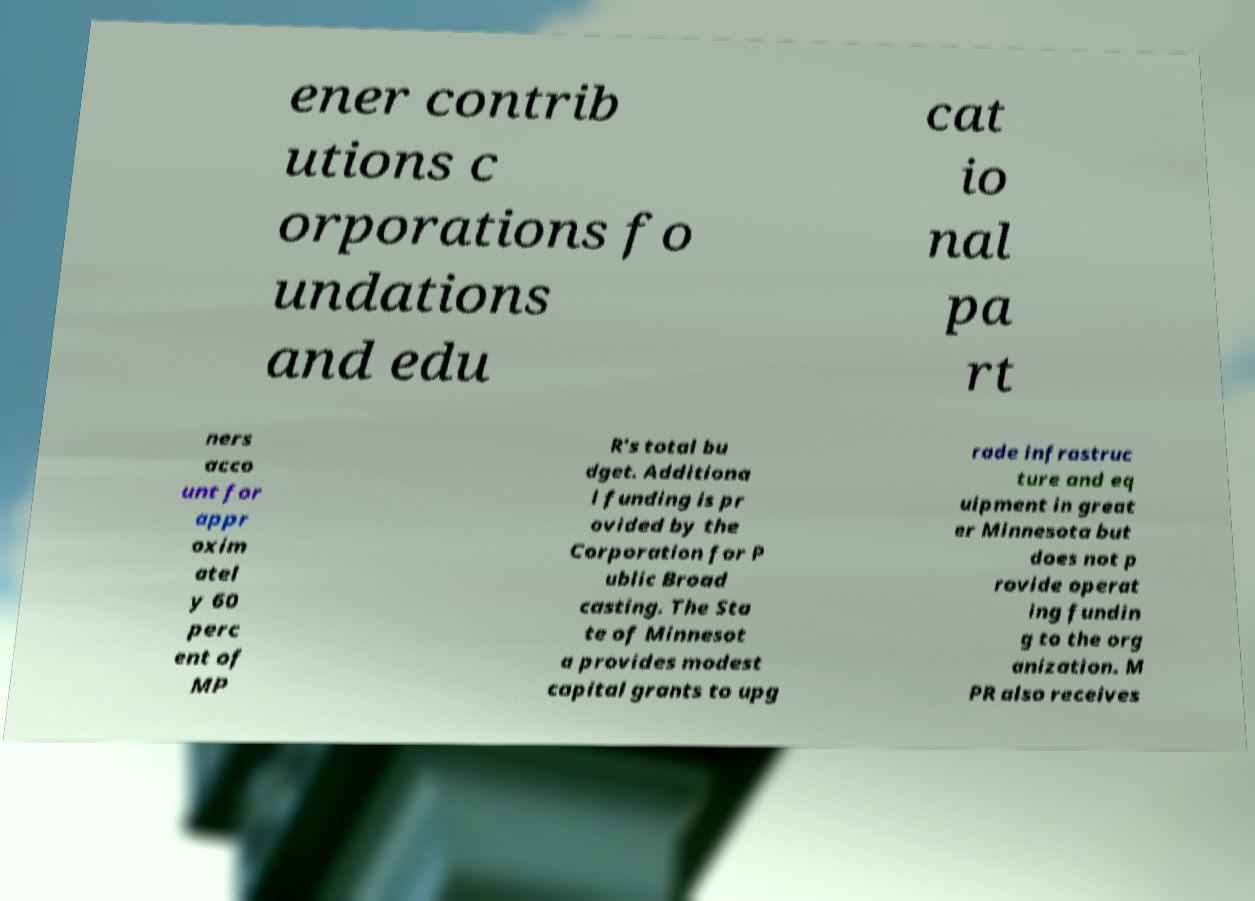Please read and relay the text visible in this image. What does it say? ener contrib utions c orporations fo undations and edu cat io nal pa rt ners acco unt for appr oxim atel y 60 perc ent of MP R's total bu dget. Additiona l funding is pr ovided by the Corporation for P ublic Broad casting. The Sta te of Minnesot a provides modest capital grants to upg rade infrastruc ture and eq uipment in great er Minnesota but does not p rovide operat ing fundin g to the org anization. M PR also receives 